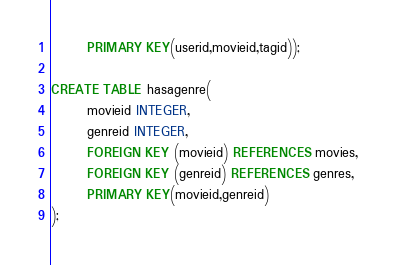<code> <loc_0><loc_0><loc_500><loc_500><_SQL_>       PRIMARY KEY(userid,movieid,tagid));

CREATE TABLE hasagenre(
       movieid INTEGER,
       genreid INTEGER,
       FOREIGN KEY (movieid) REFERENCES movies,
       FOREIGN KEY (genreid) REFERENCES genres,
       PRIMARY KEY(movieid,genreid)
);
</code> 